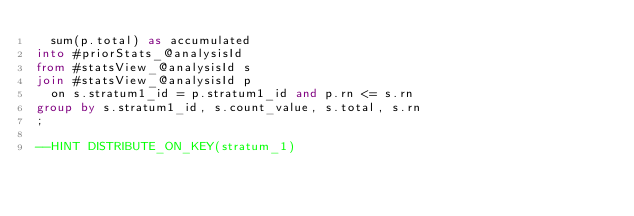<code> <loc_0><loc_0><loc_500><loc_500><_SQL_>  sum(p.total) as accumulated
into #priorStats_@analysisId
from #statsView_@analysisId s 
join #statsView_@analysisId p
  on s.stratum1_id = p.stratum1_id and p.rn <= s.rn
group by s.stratum1_id, s.count_value, s.total, s.rn
;

--HINT DISTRIBUTE_ON_KEY(stratum_1)</code> 